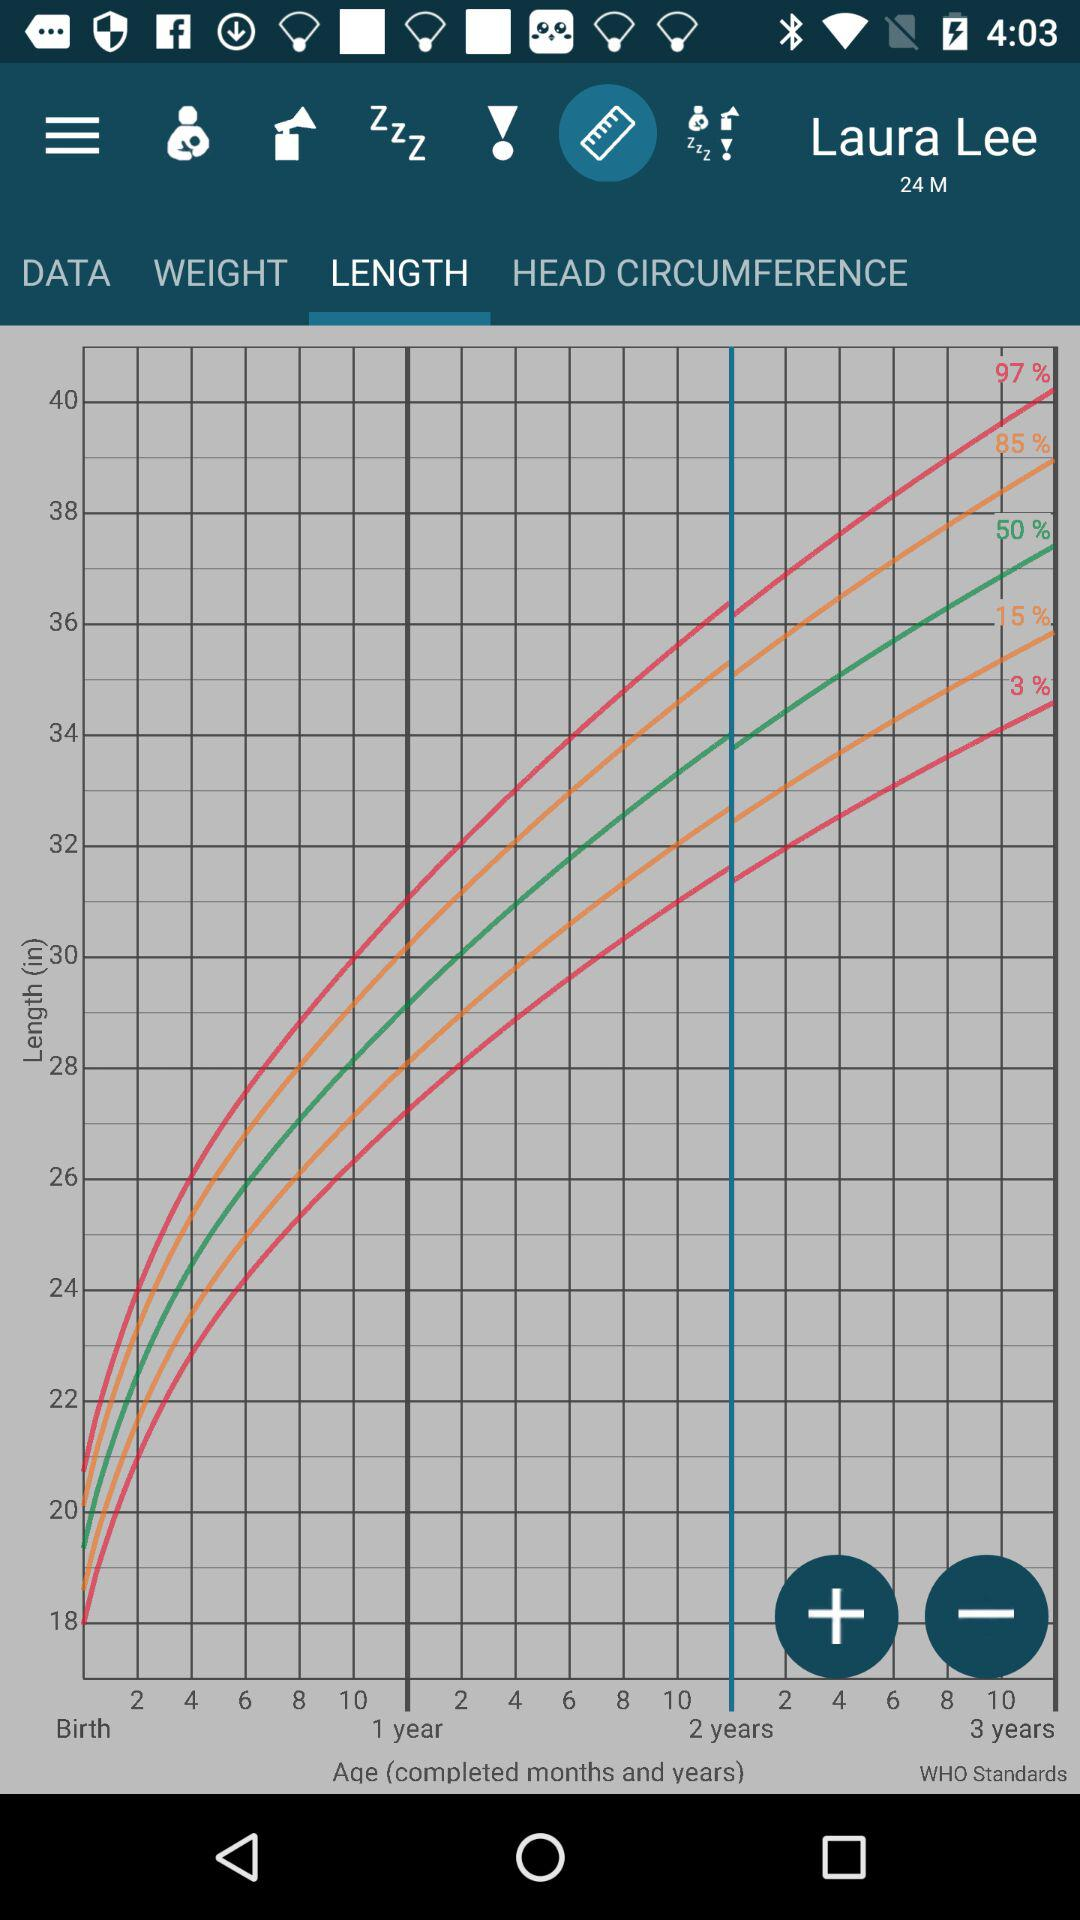What is the age of the child?
Answer the question using a single word or phrase. 24 months 